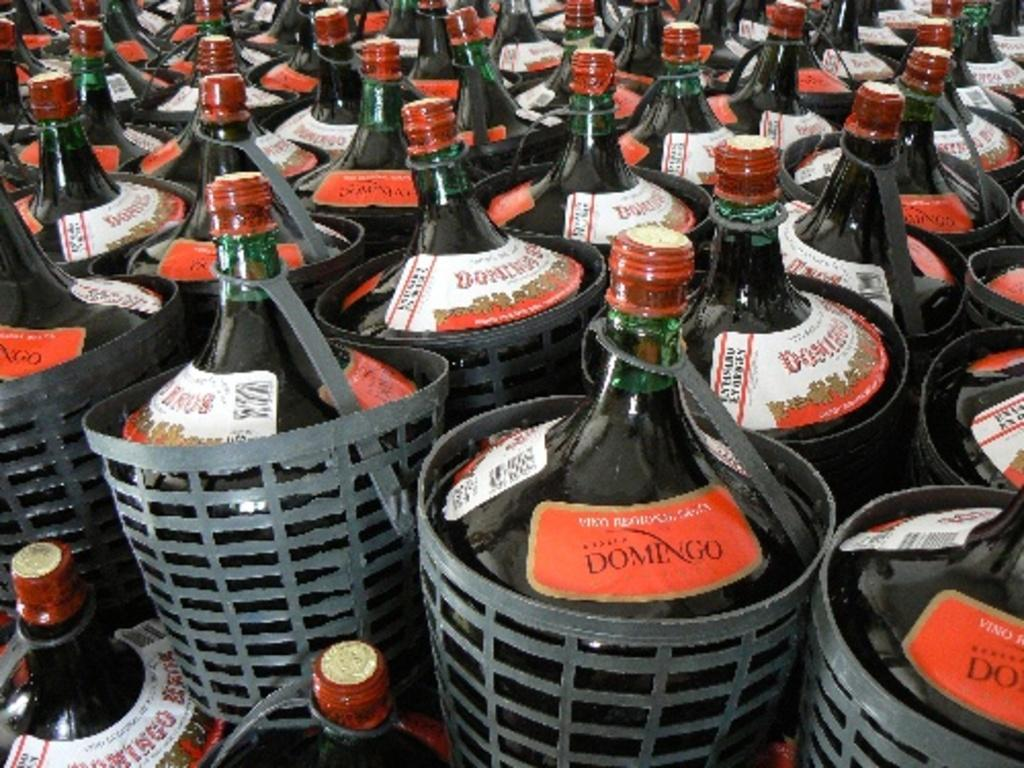What type of containers can be seen in the image? There are bottles and plastic jars in the image. Can you describe the material of the containers? The containers are made of plastic. What type of invention is being demonstrated in the image? There is no invention being demonstrated in the image; it only shows bottles and plastic jars. How does the behavior of the bottles and jars change throughout the image? The behavior of the bottles and jars does not change throughout the image, as they are stationary containers. 